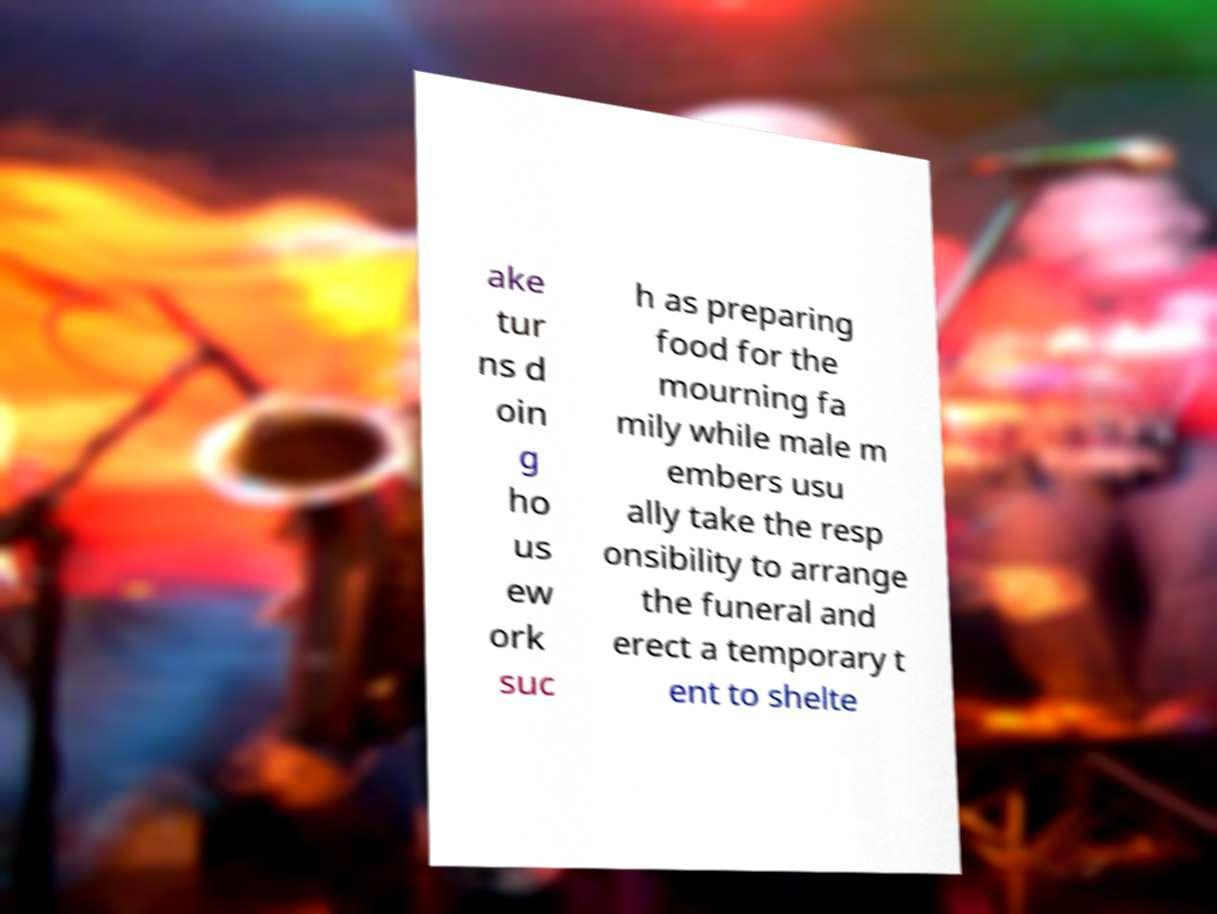Please identify and transcribe the text found in this image. ake tur ns d oin g ho us ew ork suc h as preparing food for the mourning fa mily while male m embers usu ally take the resp onsibility to arrange the funeral and erect a temporary t ent to shelte 